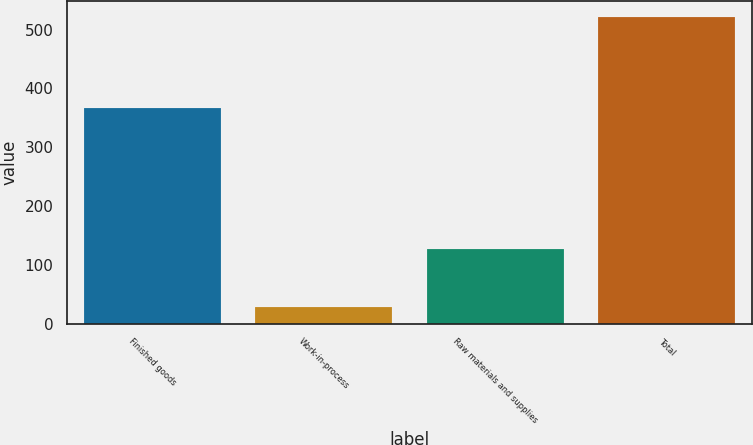<chart> <loc_0><loc_0><loc_500><loc_500><bar_chart><fcel>Finished goods<fcel>Work-in-process<fcel>Raw materials and supplies<fcel>Total<nl><fcel>367<fcel>28<fcel>127<fcel>522<nl></chart> 